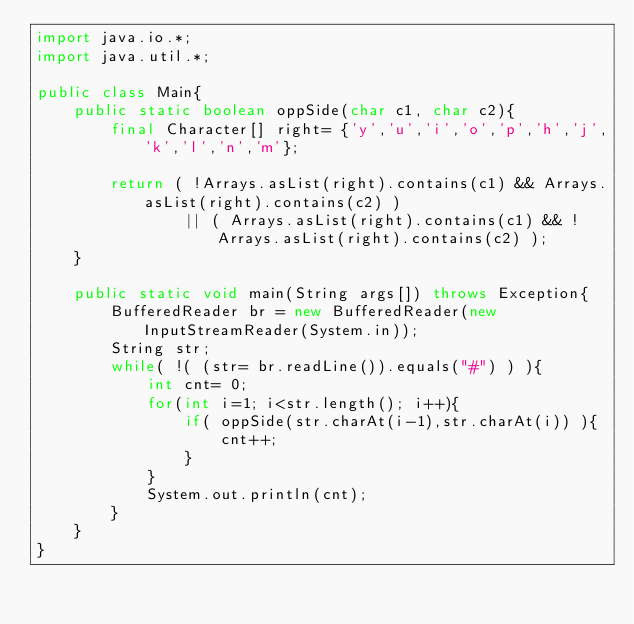<code> <loc_0><loc_0><loc_500><loc_500><_Java_>import java.io.*;
import java.util.*;

public class Main{
    public static boolean oppSide(char c1, char c2){
    	final Character[] right= {'y','u','i','o','p','h','j','k','l','n','m'};
    	
    	return ( !Arrays.asList(right).contains(c1) && Arrays.asList(right).contains(c2) )
    		    || ( Arrays.asList(right).contains(c1) && !Arrays.asList(right).contains(c2) );
    }
	
    public static void main(String args[]) throws Exception{
        BufferedReader br = new BufferedReader(new InputStreamReader(System.in));
        String str;
        while( !( (str= br.readLine()).equals("#") ) ){
        	int cnt= 0;        	
            for(int i=1; i<str.length(); i++){
            	if( oppSide(str.charAt(i-1),str.charAt(i)) ){
            		cnt++;
            	}
            }
            System.out.println(cnt);
        }
    }
}</code> 